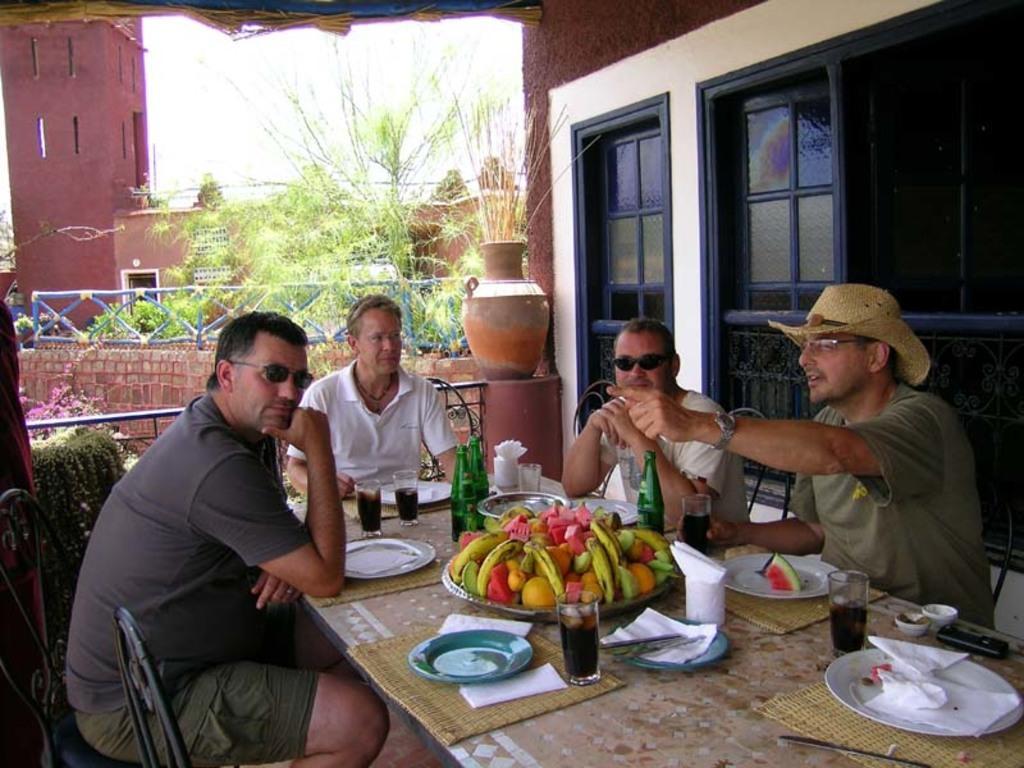Please provide a concise description of this image. In this image I can see four person sitting on the chair. On the table there is a plate,glass,tissue,fruits and a bottle. At the back side there is a building and a plants. 